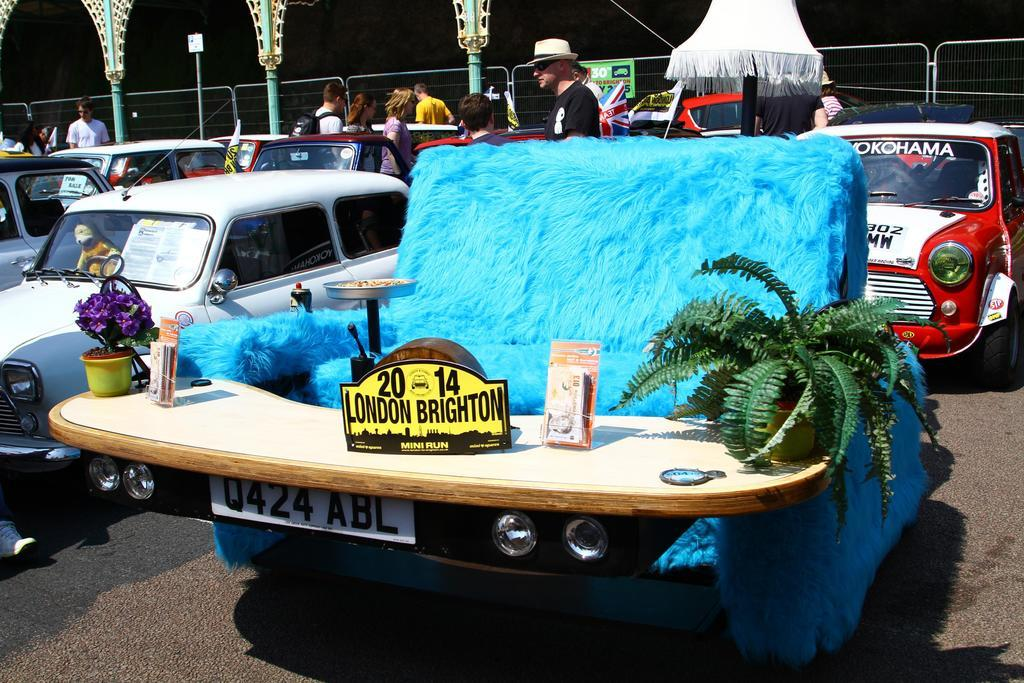What type of furniture is present in the image? There is a sofa in the image. What is placed in front of the sofa? There are plants with pots in front of the sofa. What can be seen on the boards in the image? The provided facts do not mention any details about the boards. What objects are on the table in the image? The provided facts do not mention any specific objects on the table. How many persons are visible in the image? There are persons visible in the image. What type of vehicles can be seen in the image? There are vehicles in the image. What is visible in the background of the image? There is a fence and poles in the background of the image. What channel is the water tuned to on the television in the image? There is no television or water present in the image. What day of the week is it in the image? The provided facts do not mention any information about the day of the week. 